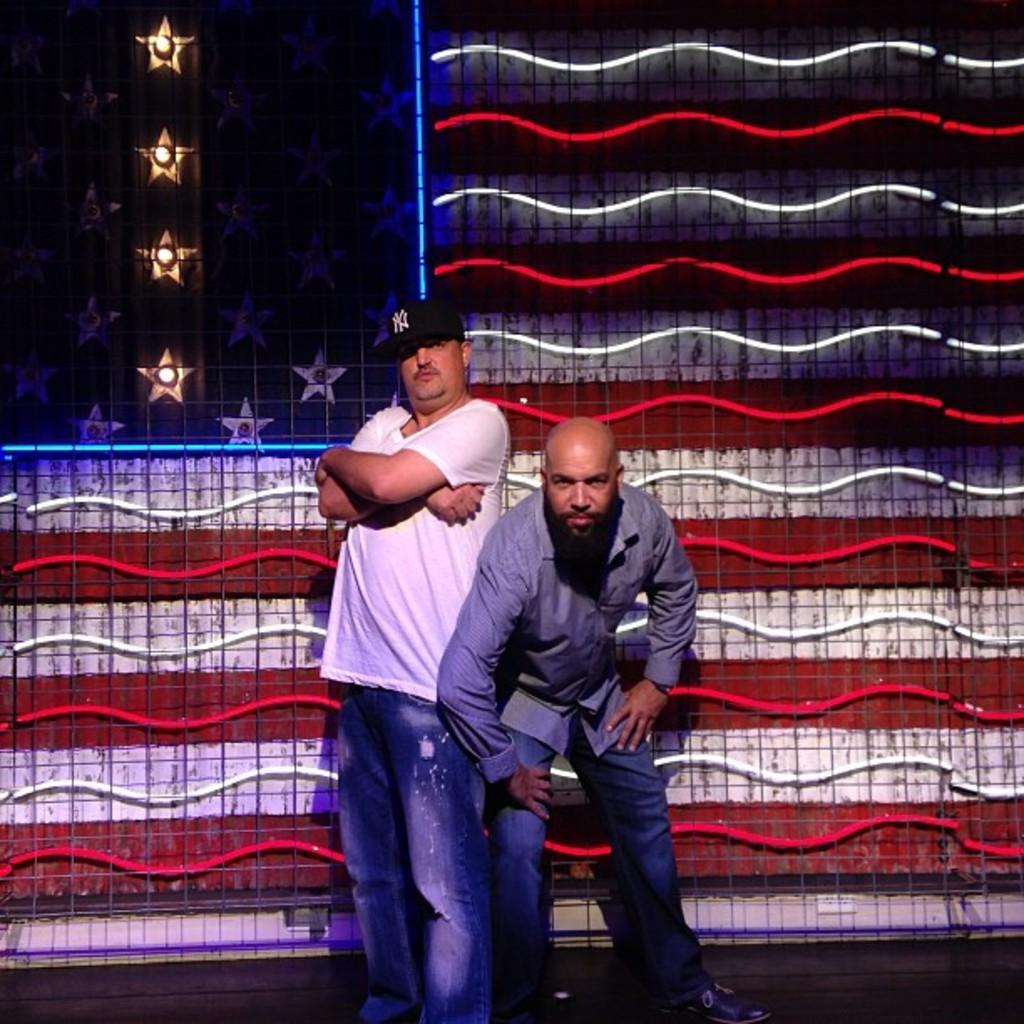How many people are present in the image? There are two men standing in the image. What can be seen in the background or surrounding the men? Lights are visible in the image. What type of ship is sailing in the background of the image? There is no ship present in the image; it only features two men and lights. What is the plot of the story being told in the image? The image does not depict a story or plot; it simply shows two men and lights. 